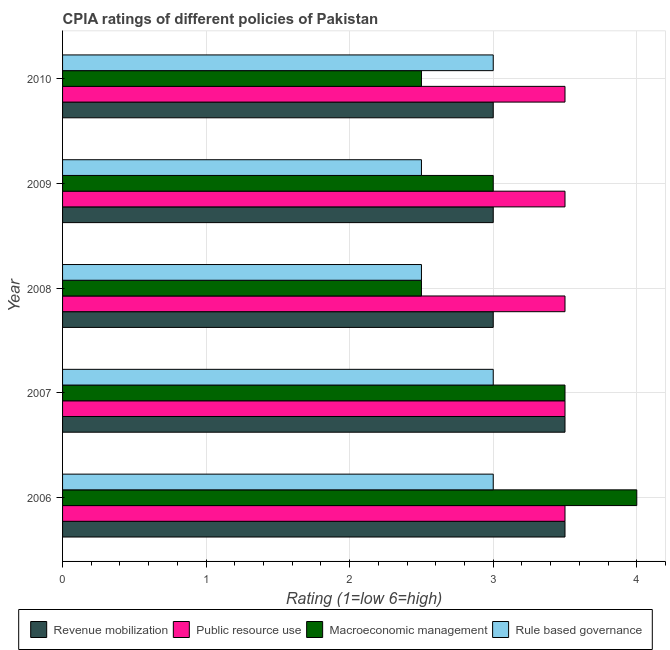How many different coloured bars are there?
Make the answer very short. 4. Are the number of bars on each tick of the Y-axis equal?
Make the answer very short. Yes. How many bars are there on the 4th tick from the top?
Your response must be concise. 4. Across all years, what is the maximum cpia rating of macroeconomic management?
Your answer should be very brief. 4. In which year was the cpia rating of public resource use maximum?
Give a very brief answer. 2006. In which year was the cpia rating of macroeconomic management minimum?
Ensure brevity in your answer.  2008. What is the difference between the cpia rating of public resource use in 2009 and that in 2010?
Give a very brief answer. 0. In how many years, is the cpia rating of macroeconomic management greater than 1.2 ?
Offer a terse response. 5. What is the ratio of the cpia rating of rule based governance in 2009 to that in 2010?
Give a very brief answer. 0.83. Is the cpia rating of macroeconomic management in 2008 less than that in 2009?
Ensure brevity in your answer.  Yes. What is the difference between the highest and the lowest cpia rating of revenue mobilization?
Keep it short and to the point. 0.5. In how many years, is the cpia rating of public resource use greater than the average cpia rating of public resource use taken over all years?
Your response must be concise. 0. What does the 3rd bar from the top in 2008 represents?
Offer a very short reply. Public resource use. What does the 4th bar from the bottom in 2006 represents?
Offer a very short reply. Rule based governance. Is it the case that in every year, the sum of the cpia rating of revenue mobilization and cpia rating of public resource use is greater than the cpia rating of macroeconomic management?
Offer a terse response. Yes. Are all the bars in the graph horizontal?
Ensure brevity in your answer.  Yes. How many years are there in the graph?
Give a very brief answer. 5. What is the difference between two consecutive major ticks on the X-axis?
Make the answer very short. 1. Are the values on the major ticks of X-axis written in scientific E-notation?
Your answer should be very brief. No. Does the graph contain grids?
Keep it short and to the point. Yes. What is the title of the graph?
Offer a terse response. CPIA ratings of different policies of Pakistan. What is the label or title of the Y-axis?
Give a very brief answer. Year. What is the Rating (1=low 6=high) of Macroeconomic management in 2006?
Your response must be concise. 4. What is the Rating (1=low 6=high) of Rule based governance in 2006?
Ensure brevity in your answer.  3. What is the Rating (1=low 6=high) in Public resource use in 2007?
Your response must be concise. 3.5. What is the Rating (1=low 6=high) in Macroeconomic management in 2007?
Provide a succinct answer. 3.5. What is the Rating (1=low 6=high) of Public resource use in 2008?
Your answer should be compact. 3.5. What is the Rating (1=low 6=high) of Macroeconomic management in 2008?
Offer a terse response. 2.5. What is the Rating (1=low 6=high) in Revenue mobilization in 2009?
Provide a succinct answer. 3. What is the Rating (1=low 6=high) in Public resource use in 2010?
Give a very brief answer. 3.5. What is the Rating (1=low 6=high) in Rule based governance in 2010?
Your answer should be very brief. 3. Across all years, what is the maximum Rating (1=low 6=high) in Revenue mobilization?
Your answer should be very brief. 3.5. Across all years, what is the maximum Rating (1=low 6=high) in Public resource use?
Ensure brevity in your answer.  3.5. Across all years, what is the maximum Rating (1=low 6=high) in Rule based governance?
Provide a short and direct response. 3. Across all years, what is the minimum Rating (1=low 6=high) of Rule based governance?
Offer a terse response. 2.5. What is the total Rating (1=low 6=high) in Public resource use in the graph?
Offer a terse response. 17.5. What is the total Rating (1=low 6=high) in Macroeconomic management in the graph?
Your answer should be compact. 15.5. What is the difference between the Rating (1=low 6=high) of Rule based governance in 2006 and that in 2007?
Make the answer very short. 0. What is the difference between the Rating (1=low 6=high) in Public resource use in 2006 and that in 2008?
Offer a terse response. 0. What is the difference between the Rating (1=low 6=high) in Macroeconomic management in 2006 and that in 2008?
Ensure brevity in your answer.  1.5. What is the difference between the Rating (1=low 6=high) of Rule based governance in 2006 and that in 2008?
Offer a very short reply. 0.5. What is the difference between the Rating (1=low 6=high) of Revenue mobilization in 2006 and that in 2009?
Your answer should be very brief. 0.5. What is the difference between the Rating (1=low 6=high) of Macroeconomic management in 2006 and that in 2009?
Keep it short and to the point. 1. What is the difference between the Rating (1=low 6=high) in Rule based governance in 2006 and that in 2009?
Offer a very short reply. 0.5. What is the difference between the Rating (1=low 6=high) of Revenue mobilization in 2006 and that in 2010?
Provide a succinct answer. 0.5. What is the difference between the Rating (1=low 6=high) in Macroeconomic management in 2006 and that in 2010?
Your answer should be very brief. 1.5. What is the difference between the Rating (1=low 6=high) of Rule based governance in 2006 and that in 2010?
Provide a short and direct response. 0. What is the difference between the Rating (1=low 6=high) of Revenue mobilization in 2007 and that in 2008?
Your response must be concise. 0.5. What is the difference between the Rating (1=low 6=high) of Rule based governance in 2007 and that in 2008?
Your answer should be very brief. 0.5. What is the difference between the Rating (1=low 6=high) of Revenue mobilization in 2007 and that in 2009?
Give a very brief answer. 0.5. What is the difference between the Rating (1=low 6=high) in Public resource use in 2007 and that in 2010?
Give a very brief answer. 0. What is the difference between the Rating (1=low 6=high) of Macroeconomic management in 2007 and that in 2010?
Your answer should be very brief. 1. What is the difference between the Rating (1=low 6=high) of Rule based governance in 2007 and that in 2010?
Your response must be concise. 0. What is the difference between the Rating (1=low 6=high) in Public resource use in 2008 and that in 2009?
Your response must be concise. 0. What is the difference between the Rating (1=low 6=high) of Macroeconomic management in 2008 and that in 2009?
Your answer should be compact. -0.5. What is the difference between the Rating (1=low 6=high) in Rule based governance in 2008 and that in 2009?
Your answer should be compact. 0. What is the difference between the Rating (1=low 6=high) in Revenue mobilization in 2008 and that in 2010?
Provide a short and direct response. 0. What is the difference between the Rating (1=low 6=high) in Macroeconomic management in 2008 and that in 2010?
Give a very brief answer. 0. What is the difference between the Rating (1=low 6=high) of Macroeconomic management in 2009 and that in 2010?
Ensure brevity in your answer.  0.5. What is the difference between the Rating (1=low 6=high) in Revenue mobilization in 2006 and the Rating (1=low 6=high) in Rule based governance in 2007?
Ensure brevity in your answer.  0.5. What is the difference between the Rating (1=low 6=high) in Public resource use in 2006 and the Rating (1=low 6=high) in Macroeconomic management in 2007?
Offer a terse response. 0. What is the difference between the Rating (1=low 6=high) of Revenue mobilization in 2006 and the Rating (1=low 6=high) of Rule based governance in 2008?
Ensure brevity in your answer.  1. What is the difference between the Rating (1=low 6=high) of Public resource use in 2006 and the Rating (1=low 6=high) of Macroeconomic management in 2008?
Make the answer very short. 1. What is the difference between the Rating (1=low 6=high) of Public resource use in 2006 and the Rating (1=low 6=high) of Rule based governance in 2008?
Provide a short and direct response. 1. What is the difference between the Rating (1=low 6=high) in Revenue mobilization in 2006 and the Rating (1=low 6=high) in Public resource use in 2009?
Your answer should be compact. 0. What is the difference between the Rating (1=low 6=high) in Revenue mobilization in 2006 and the Rating (1=low 6=high) in Macroeconomic management in 2009?
Give a very brief answer. 0.5. What is the difference between the Rating (1=low 6=high) in Revenue mobilization in 2006 and the Rating (1=low 6=high) in Rule based governance in 2009?
Provide a short and direct response. 1. What is the difference between the Rating (1=low 6=high) of Public resource use in 2006 and the Rating (1=low 6=high) of Rule based governance in 2009?
Your answer should be very brief. 1. What is the difference between the Rating (1=low 6=high) in Macroeconomic management in 2006 and the Rating (1=low 6=high) in Rule based governance in 2009?
Keep it short and to the point. 1.5. What is the difference between the Rating (1=low 6=high) of Public resource use in 2006 and the Rating (1=low 6=high) of Macroeconomic management in 2010?
Provide a succinct answer. 1. What is the difference between the Rating (1=low 6=high) of Macroeconomic management in 2006 and the Rating (1=low 6=high) of Rule based governance in 2010?
Your answer should be very brief. 1. What is the difference between the Rating (1=low 6=high) in Revenue mobilization in 2007 and the Rating (1=low 6=high) in Public resource use in 2008?
Your answer should be very brief. 0. What is the difference between the Rating (1=low 6=high) in Revenue mobilization in 2007 and the Rating (1=low 6=high) in Macroeconomic management in 2008?
Offer a terse response. 1. What is the difference between the Rating (1=low 6=high) of Revenue mobilization in 2007 and the Rating (1=low 6=high) of Public resource use in 2009?
Keep it short and to the point. 0. What is the difference between the Rating (1=low 6=high) of Revenue mobilization in 2007 and the Rating (1=low 6=high) of Rule based governance in 2009?
Your answer should be very brief. 1. What is the difference between the Rating (1=low 6=high) in Public resource use in 2007 and the Rating (1=low 6=high) in Macroeconomic management in 2009?
Provide a succinct answer. 0.5. What is the difference between the Rating (1=low 6=high) of Public resource use in 2007 and the Rating (1=low 6=high) of Rule based governance in 2009?
Keep it short and to the point. 1. What is the difference between the Rating (1=low 6=high) in Revenue mobilization in 2007 and the Rating (1=low 6=high) in Public resource use in 2010?
Offer a terse response. 0. What is the difference between the Rating (1=low 6=high) of Public resource use in 2007 and the Rating (1=low 6=high) of Rule based governance in 2010?
Make the answer very short. 0.5. What is the difference between the Rating (1=low 6=high) in Revenue mobilization in 2008 and the Rating (1=low 6=high) in Public resource use in 2009?
Offer a very short reply. -0.5. What is the difference between the Rating (1=low 6=high) of Revenue mobilization in 2008 and the Rating (1=low 6=high) of Macroeconomic management in 2009?
Your answer should be very brief. 0. What is the difference between the Rating (1=low 6=high) of Revenue mobilization in 2008 and the Rating (1=low 6=high) of Rule based governance in 2009?
Offer a terse response. 0.5. What is the difference between the Rating (1=low 6=high) in Public resource use in 2008 and the Rating (1=low 6=high) in Macroeconomic management in 2009?
Ensure brevity in your answer.  0.5. What is the difference between the Rating (1=low 6=high) in Public resource use in 2008 and the Rating (1=low 6=high) in Rule based governance in 2009?
Ensure brevity in your answer.  1. What is the difference between the Rating (1=low 6=high) in Revenue mobilization in 2008 and the Rating (1=low 6=high) in Public resource use in 2010?
Offer a terse response. -0.5. What is the difference between the Rating (1=low 6=high) in Revenue mobilization in 2008 and the Rating (1=low 6=high) in Macroeconomic management in 2010?
Offer a terse response. 0.5. What is the difference between the Rating (1=low 6=high) of Macroeconomic management in 2008 and the Rating (1=low 6=high) of Rule based governance in 2010?
Keep it short and to the point. -0.5. What is the difference between the Rating (1=low 6=high) of Revenue mobilization in 2009 and the Rating (1=low 6=high) of Macroeconomic management in 2010?
Give a very brief answer. 0.5. What is the difference between the Rating (1=low 6=high) of Revenue mobilization in 2009 and the Rating (1=low 6=high) of Rule based governance in 2010?
Offer a terse response. 0. What is the average Rating (1=low 6=high) of Macroeconomic management per year?
Your response must be concise. 3.1. What is the average Rating (1=low 6=high) of Rule based governance per year?
Offer a very short reply. 2.8. In the year 2006, what is the difference between the Rating (1=low 6=high) in Revenue mobilization and Rating (1=low 6=high) in Macroeconomic management?
Your answer should be compact. -0.5. In the year 2006, what is the difference between the Rating (1=low 6=high) of Public resource use and Rating (1=low 6=high) of Macroeconomic management?
Provide a succinct answer. -0.5. In the year 2006, what is the difference between the Rating (1=low 6=high) in Public resource use and Rating (1=low 6=high) in Rule based governance?
Your answer should be very brief. 0.5. In the year 2007, what is the difference between the Rating (1=low 6=high) of Macroeconomic management and Rating (1=low 6=high) of Rule based governance?
Offer a very short reply. 0.5. In the year 2008, what is the difference between the Rating (1=low 6=high) of Revenue mobilization and Rating (1=low 6=high) of Public resource use?
Your answer should be compact. -0.5. In the year 2008, what is the difference between the Rating (1=low 6=high) of Revenue mobilization and Rating (1=low 6=high) of Macroeconomic management?
Offer a terse response. 0.5. In the year 2009, what is the difference between the Rating (1=low 6=high) of Revenue mobilization and Rating (1=low 6=high) of Public resource use?
Ensure brevity in your answer.  -0.5. In the year 2009, what is the difference between the Rating (1=low 6=high) of Revenue mobilization and Rating (1=low 6=high) of Macroeconomic management?
Give a very brief answer. 0. In the year 2009, what is the difference between the Rating (1=low 6=high) in Revenue mobilization and Rating (1=low 6=high) in Rule based governance?
Offer a terse response. 0.5. In the year 2009, what is the difference between the Rating (1=low 6=high) in Public resource use and Rating (1=low 6=high) in Rule based governance?
Give a very brief answer. 1. In the year 2009, what is the difference between the Rating (1=low 6=high) of Macroeconomic management and Rating (1=low 6=high) of Rule based governance?
Offer a very short reply. 0.5. In the year 2010, what is the difference between the Rating (1=low 6=high) of Revenue mobilization and Rating (1=low 6=high) of Macroeconomic management?
Your answer should be very brief. 0.5. In the year 2010, what is the difference between the Rating (1=low 6=high) of Revenue mobilization and Rating (1=low 6=high) of Rule based governance?
Make the answer very short. 0. In the year 2010, what is the difference between the Rating (1=low 6=high) of Public resource use and Rating (1=low 6=high) of Macroeconomic management?
Provide a succinct answer. 1. In the year 2010, what is the difference between the Rating (1=low 6=high) in Macroeconomic management and Rating (1=low 6=high) in Rule based governance?
Your answer should be very brief. -0.5. What is the ratio of the Rating (1=low 6=high) of Macroeconomic management in 2006 to that in 2007?
Offer a very short reply. 1.14. What is the ratio of the Rating (1=low 6=high) in Rule based governance in 2006 to that in 2007?
Offer a terse response. 1. What is the ratio of the Rating (1=low 6=high) in Public resource use in 2006 to that in 2008?
Give a very brief answer. 1. What is the ratio of the Rating (1=low 6=high) in Macroeconomic management in 2006 to that in 2008?
Offer a very short reply. 1.6. What is the ratio of the Rating (1=low 6=high) in Rule based governance in 2006 to that in 2008?
Give a very brief answer. 1.2. What is the ratio of the Rating (1=low 6=high) in Revenue mobilization in 2006 to that in 2009?
Offer a terse response. 1.17. What is the ratio of the Rating (1=low 6=high) in Revenue mobilization in 2006 to that in 2010?
Your answer should be compact. 1.17. What is the ratio of the Rating (1=low 6=high) in Public resource use in 2007 to that in 2008?
Offer a very short reply. 1. What is the ratio of the Rating (1=low 6=high) in Macroeconomic management in 2007 to that in 2008?
Your response must be concise. 1.4. What is the ratio of the Rating (1=low 6=high) of Public resource use in 2007 to that in 2009?
Keep it short and to the point. 1. What is the ratio of the Rating (1=low 6=high) of Macroeconomic management in 2007 to that in 2009?
Offer a very short reply. 1.17. What is the ratio of the Rating (1=low 6=high) in Rule based governance in 2007 to that in 2009?
Your answer should be very brief. 1.2. What is the ratio of the Rating (1=low 6=high) of Revenue mobilization in 2007 to that in 2010?
Make the answer very short. 1.17. What is the ratio of the Rating (1=low 6=high) of Public resource use in 2007 to that in 2010?
Your response must be concise. 1. What is the ratio of the Rating (1=low 6=high) in Macroeconomic management in 2007 to that in 2010?
Offer a very short reply. 1.4. What is the ratio of the Rating (1=low 6=high) in Rule based governance in 2007 to that in 2010?
Keep it short and to the point. 1. What is the ratio of the Rating (1=low 6=high) in Public resource use in 2008 to that in 2009?
Ensure brevity in your answer.  1. What is the ratio of the Rating (1=low 6=high) of Rule based governance in 2008 to that in 2009?
Your response must be concise. 1. What is the ratio of the Rating (1=low 6=high) of Revenue mobilization in 2008 to that in 2010?
Keep it short and to the point. 1. What is the ratio of the Rating (1=low 6=high) of Public resource use in 2008 to that in 2010?
Your response must be concise. 1. What is the ratio of the Rating (1=low 6=high) in Rule based governance in 2008 to that in 2010?
Give a very brief answer. 0.83. What is the ratio of the Rating (1=low 6=high) in Rule based governance in 2009 to that in 2010?
Your response must be concise. 0.83. What is the difference between the highest and the second highest Rating (1=low 6=high) in Revenue mobilization?
Offer a terse response. 0. What is the difference between the highest and the second highest Rating (1=low 6=high) in Public resource use?
Your response must be concise. 0. What is the difference between the highest and the second highest Rating (1=low 6=high) in Macroeconomic management?
Make the answer very short. 0.5. What is the difference between the highest and the lowest Rating (1=low 6=high) of Revenue mobilization?
Your answer should be compact. 0.5. What is the difference between the highest and the lowest Rating (1=low 6=high) in Public resource use?
Your response must be concise. 0. 